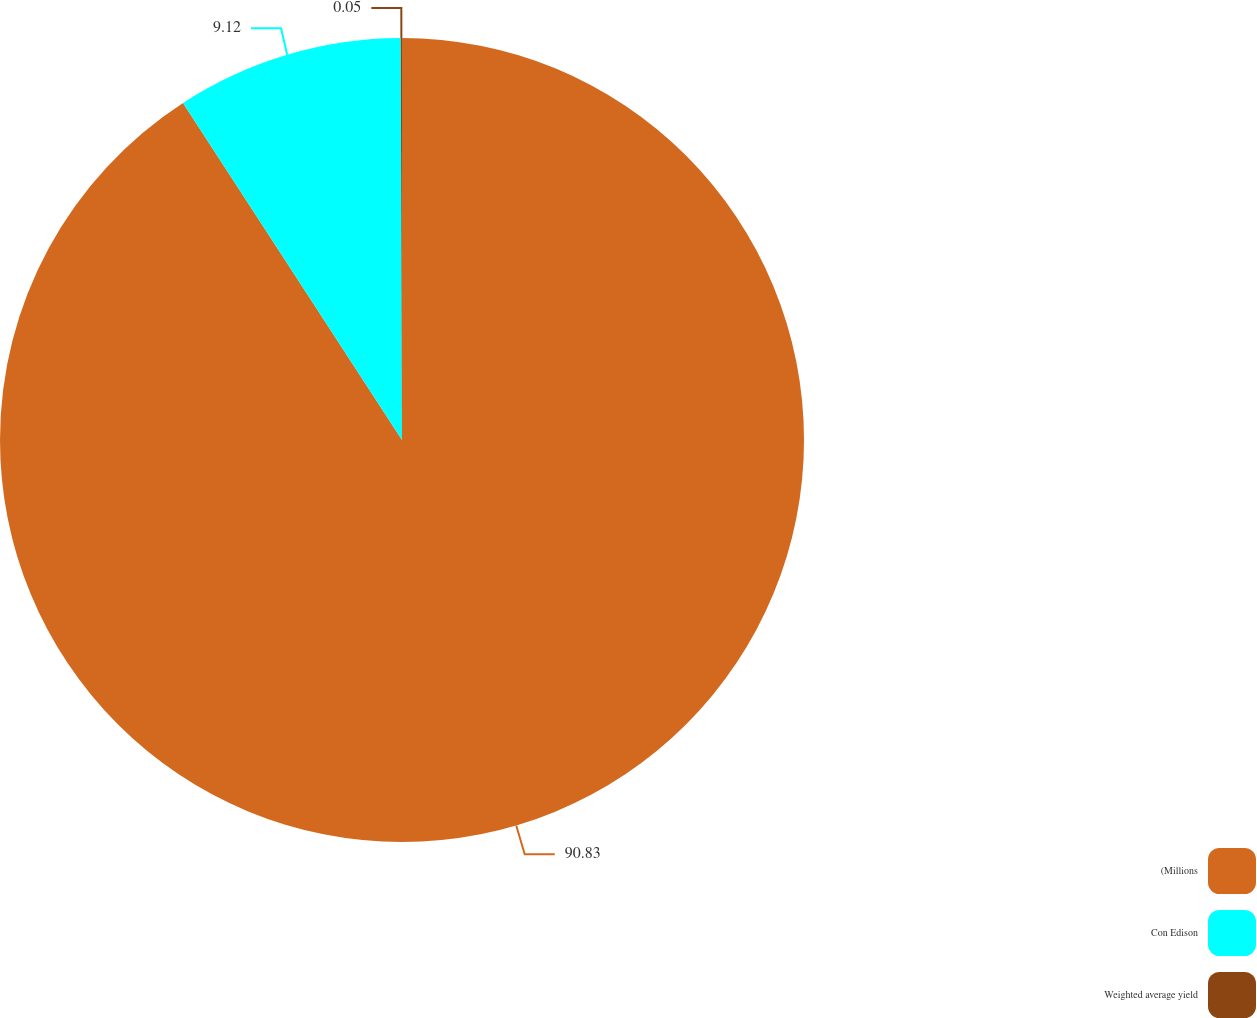Convert chart to OTSL. <chart><loc_0><loc_0><loc_500><loc_500><pie_chart><fcel>(Millions<fcel>Con Edison<fcel>Weighted average yield<nl><fcel>90.83%<fcel>9.12%<fcel>0.05%<nl></chart> 